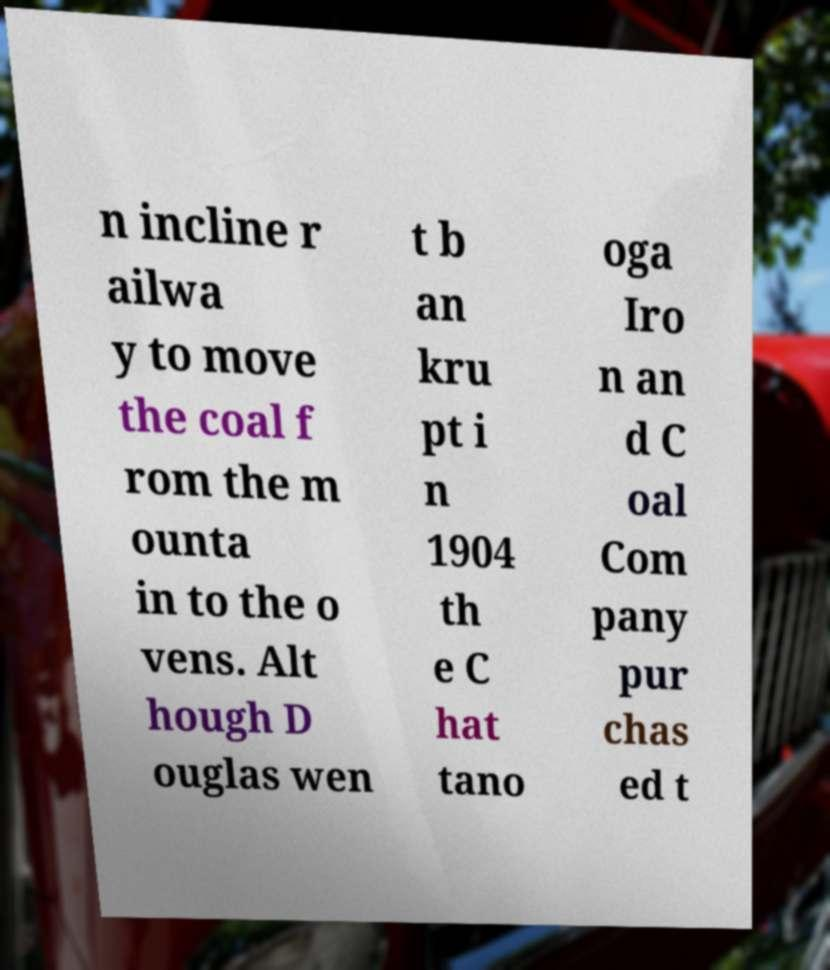I need the written content from this picture converted into text. Can you do that? n incline r ailwa y to move the coal f rom the m ounta in to the o vens. Alt hough D ouglas wen t b an kru pt i n 1904 th e C hat tano oga Iro n an d C oal Com pany pur chas ed t 